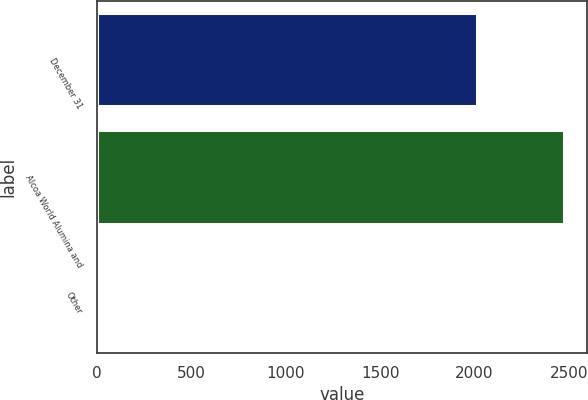Convert chart to OTSL. <chart><loc_0><loc_0><loc_500><loc_500><bar_chart><fcel>December 31<fcel>Alcoa World Alumina and<fcel>Other<nl><fcel>2014<fcel>2474<fcel>14<nl></chart> 